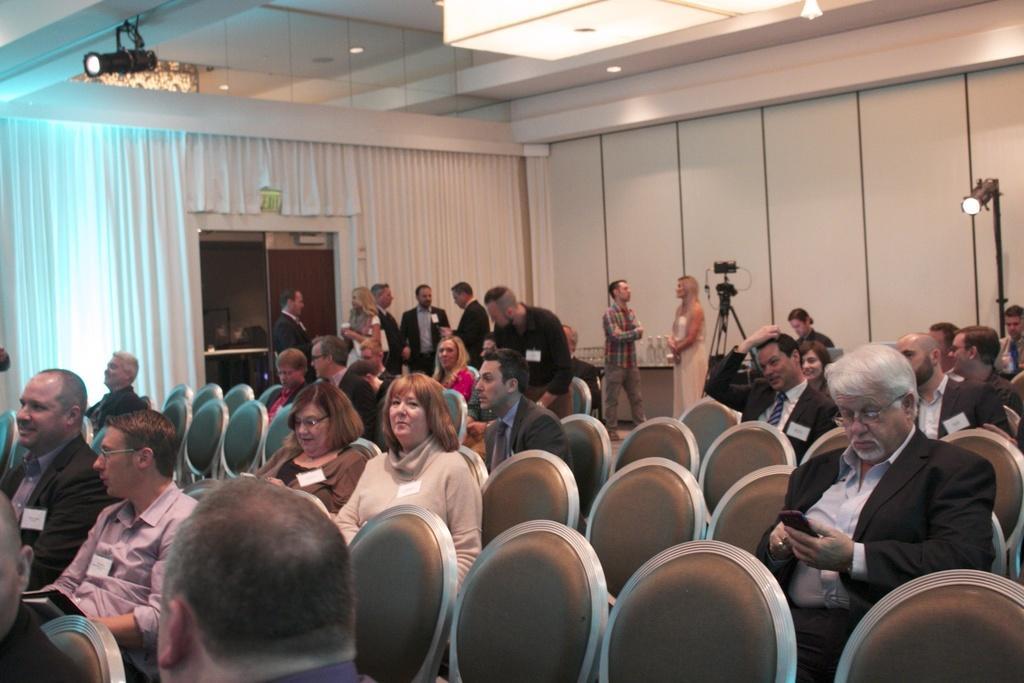Could you give a brief overview of what you see in this image? In this image we can see a few people who are sitting on a chair. In the background we can see a few people who are standing and there is a person standing here and he is speaking on a microphone. This is a roof with lighting arrangement. 